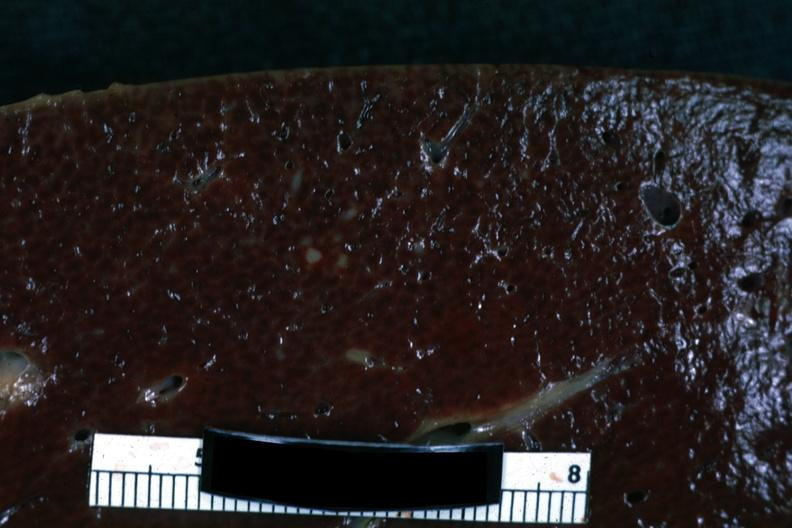how does this image show cut surface?
Answer the question using a single word or phrase. With focal infiltrate 